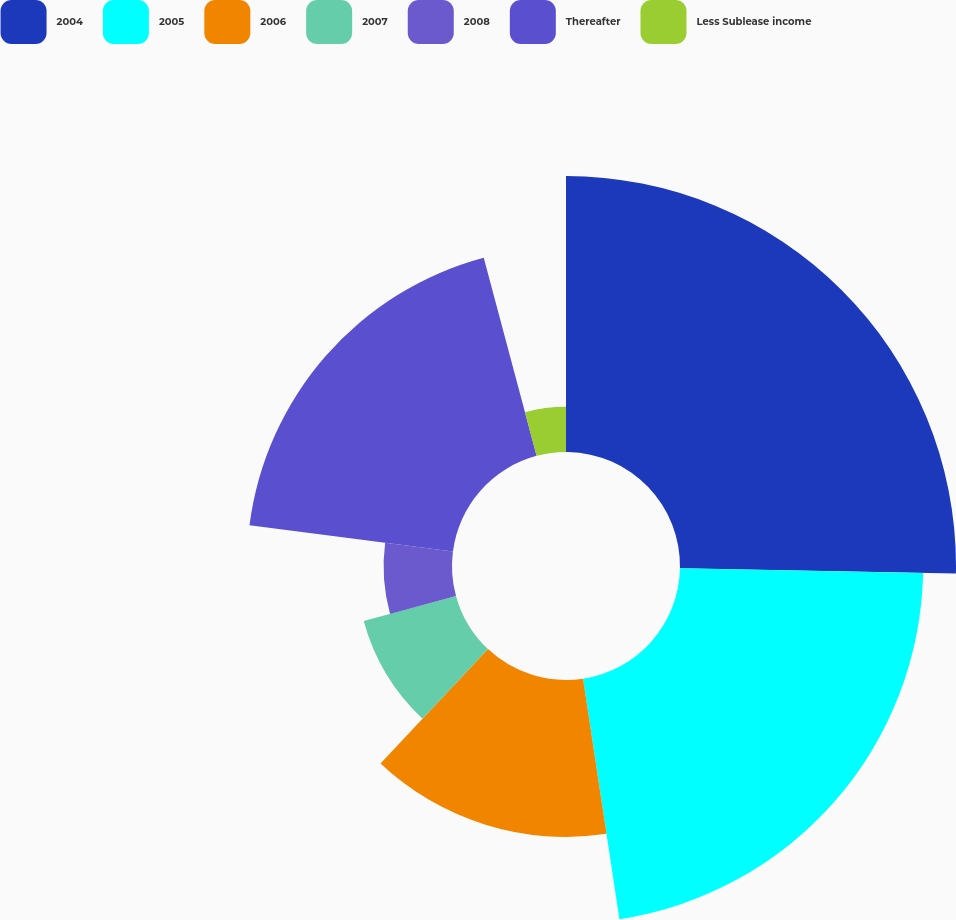<chart> <loc_0><loc_0><loc_500><loc_500><pie_chart><fcel>2004<fcel>2005<fcel>2006<fcel>2007<fcel>2008<fcel>Thereafter<fcel>Less Sublease income<nl><fcel>25.31%<fcel>22.3%<fcel>14.39%<fcel>8.77%<fcel>6.27%<fcel>18.81%<fcel>4.15%<nl></chart> 